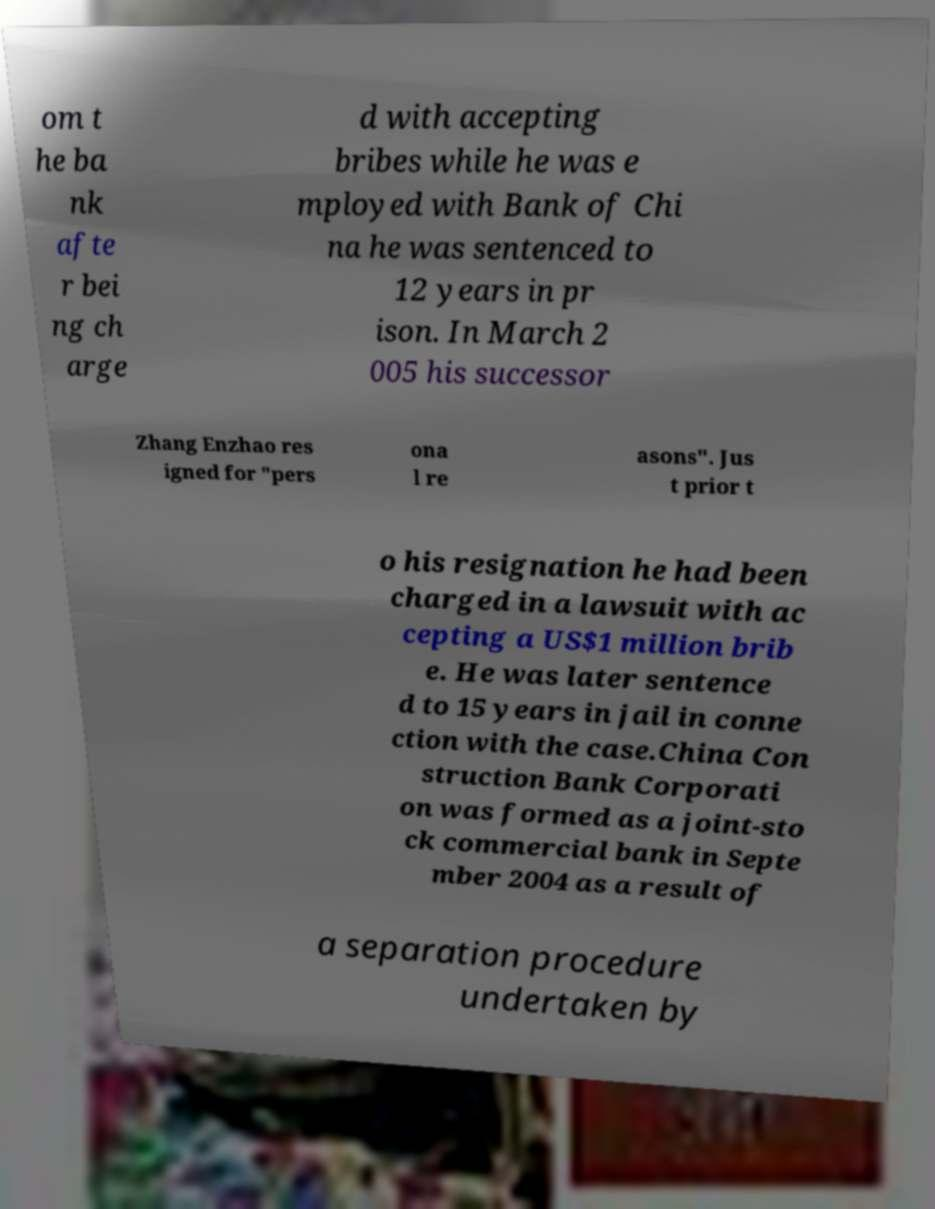There's text embedded in this image that I need extracted. Can you transcribe it verbatim? om t he ba nk afte r bei ng ch arge d with accepting bribes while he was e mployed with Bank of Chi na he was sentenced to 12 years in pr ison. In March 2 005 his successor Zhang Enzhao res igned for "pers ona l re asons". Jus t prior t o his resignation he had been charged in a lawsuit with ac cepting a US$1 million brib e. He was later sentence d to 15 years in jail in conne ction with the case.China Con struction Bank Corporati on was formed as a joint-sto ck commercial bank in Septe mber 2004 as a result of a separation procedure undertaken by 